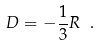Convert formula to latex. <formula><loc_0><loc_0><loc_500><loc_500>D = - \frac { 1 } { 3 } R \ .</formula> 